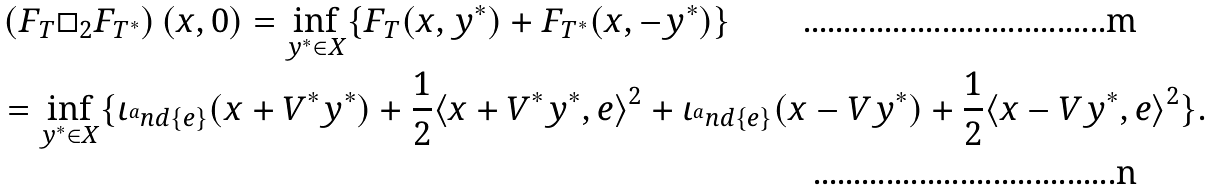Convert formula to latex. <formula><loc_0><loc_0><loc_500><loc_500>& \left ( F _ { T } \Box _ { 2 } F _ { T ^ { * } } \right ) ( x , 0 ) = \inf _ { y ^ { * } \in X } \{ F _ { T } ( x , y ^ { * } ) + F _ { T ^ { * } } ( x , - y ^ { * } ) \} \\ & = \inf _ { y ^ { * } \in X } \{ \iota _ { ^ { a } n d \{ e \} } ( x + V ^ { * } y ^ { * } ) + \frac { 1 } { 2 } \langle x + V ^ { * } y ^ { * } , e \rangle ^ { 2 } + \iota _ { ^ { a } n d \{ e \} } ( x - V y ^ { * } ) + \frac { 1 } { 2 } \langle x - V y ^ { * } , e \rangle ^ { 2 } \} .</formula> 